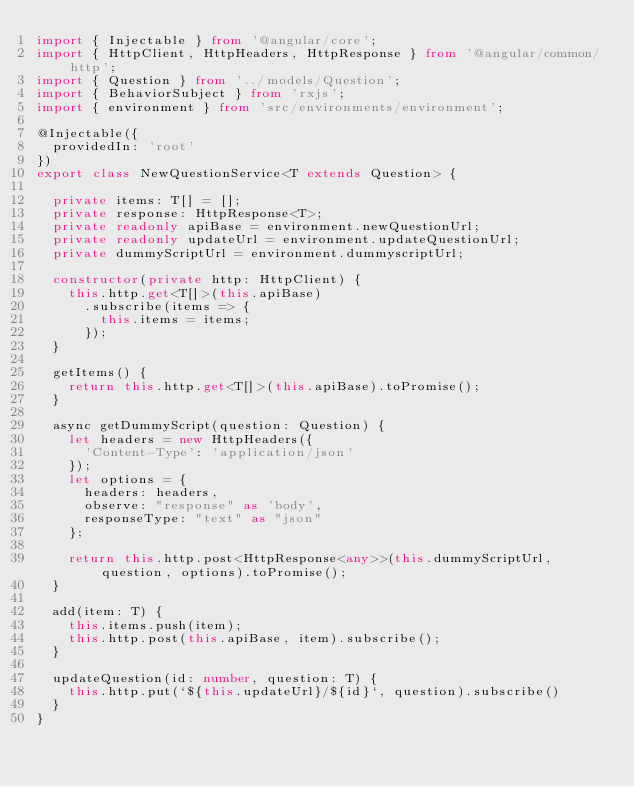<code> <loc_0><loc_0><loc_500><loc_500><_TypeScript_>import { Injectable } from '@angular/core';
import { HttpClient, HttpHeaders, HttpResponse } from '@angular/common/http';
import { Question } from '../models/Question';
import { BehaviorSubject } from 'rxjs';
import { environment } from 'src/environments/environment';

@Injectable({
  providedIn: 'root'
})
export class NewQuestionService<T extends Question> {

  private items: T[] = [];
  private response: HttpResponse<T>;
  private readonly apiBase = environment.newQuestionUrl;
  private readonly updateUrl = environment.updateQuestionUrl;
  private dummyScriptUrl = environment.dummyscriptUrl;

  constructor(private http: HttpClient) {
    this.http.get<T[]>(this.apiBase)
      .subscribe(items => {
        this.items = items;
      });
  }

  getItems() {
    return this.http.get<T[]>(this.apiBase).toPromise();
  }

  async getDummyScript(question: Question) {
    let headers = new HttpHeaders({
      'Content-Type': 'application/json'
    });
    let options = {
      headers: headers,
      observe: "response" as 'body',
      responseType: "text" as "json"
    };

    return this.http.post<HttpResponse<any>>(this.dummyScriptUrl, question, options).toPromise();
  }

  add(item: T) {
    this.items.push(item);
    this.http.post(this.apiBase, item).subscribe();
  }

  updateQuestion(id: number, question: T) {
    this.http.put(`${this.updateUrl}/${id}`, question).subscribe()
  }
}</code> 